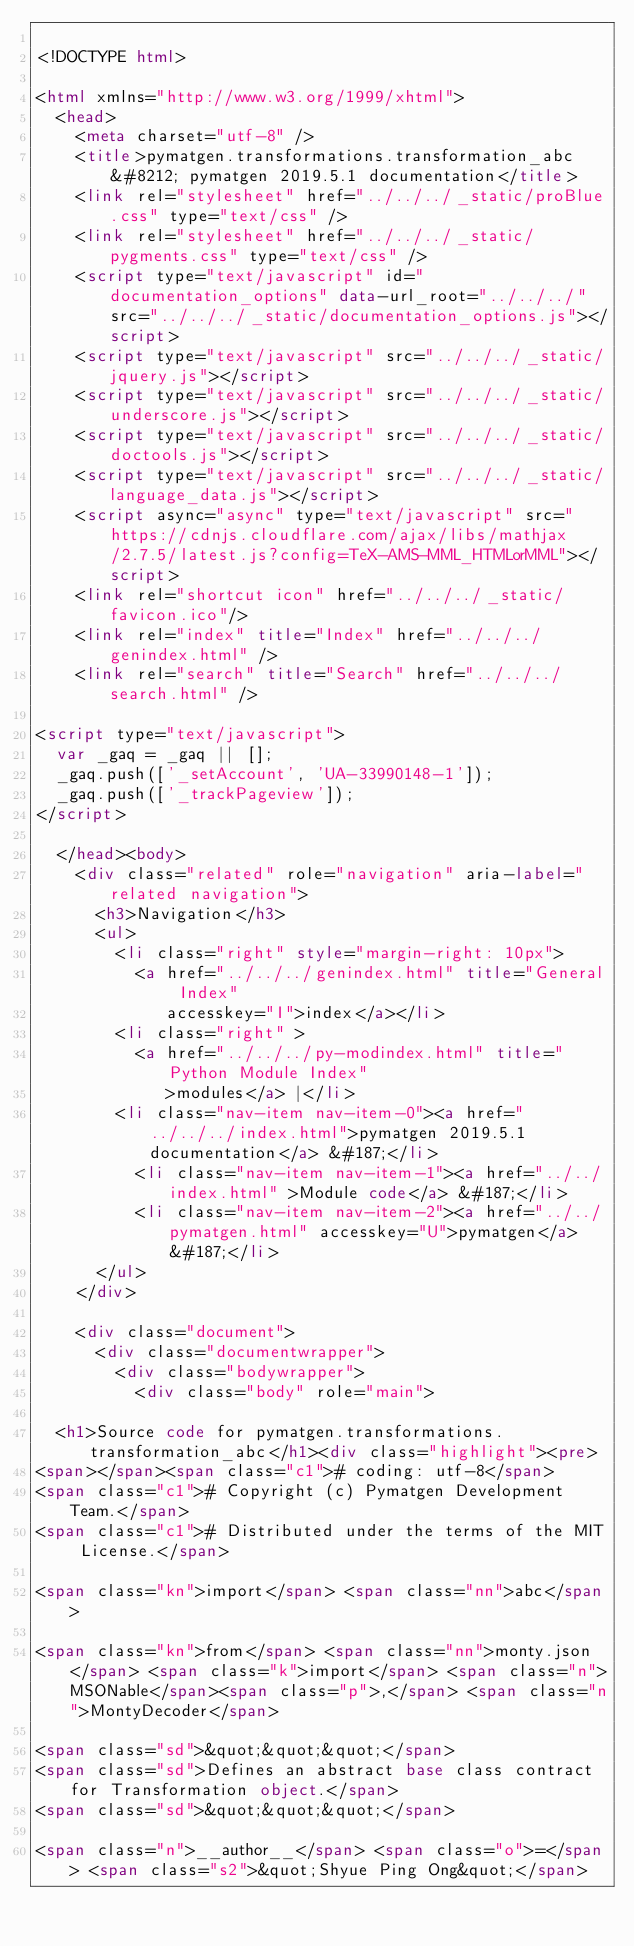Convert code to text. <code><loc_0><loc_0><loc_500><loc_500><_HTML_>
<!DOCTYPE html>

<html xmlns="http://www.w3.org/1999/xhtml">
  <head>
    <meta charset="utf-8" />
    <title>pymatgen.transformations.transformation_abc &#8212; pymatgen 2019.5.1 documentation</title>
    <link rel="stylesheet" href="../../../_static/proBlue.css" type="text/css" />
    <link rel="stylesheet" href="../../../_static/pygments.css" type="text/css" />
    <script type="text/javascript" id="documentation_options" data-url_root="../../../" src="../../../_static/documentation_options.js"></script>
    <script type="text/javascript" src="../../../_static/jquery.js"></script>
    <script type="text/javascript" src="../../../_static/underscore.js"></script>
    <script type="text/javascript" src="../../../_static/doctools.js"></script>
    <script type="text/javascript" src="../../../_static/language_data.js"></script>
    <script async="async" type="text/javascript" src="https://cdnjs.cloudflare.com/ajax/libs/mathjax/2.7.5/latest.js?config=TeX-AMS-MML_HTMLorMML"></script>
    <link rel="shortcut icon" href="../../../_static/favicon.ico"/>
    <link rel="index" title="Index" href="../../../genindex.html" />
    <link rel="search" title="Search" href="../../../search.html" />
 
<script type="text/javascript">
  var _gaq = _gaq || [];
  _gaq.push(['_setAccount', 'UA-33990148-1']);
  _gaq.push(['_trackPageview']);
</script>

  </head><body>
    <div class="related" role="navigation" aria-label="related navigation">
      <h3>Navigation</h3>
      <ul>
        <li class="right" style="margin-right: 10px">
          <a href="../../../genindex.html" title="General Index"
             accesskey="I">index</a></li>
        <li class="right" >
          <a href="../../../py-modindex.html" title="Python Module Index"
             >modules</a> |</li>
        <li class="nav-item nav-item-0"><a href="../../../index.html">pymatgen 2019.5.1 documentation</a> &#187;</li>
          <li class="nav-item nav-item-1"><a href="../../index.html" >Module code</a> &#187;</li>
          <li class="nav-item nav-item-2"><a href="../../pymatgen.html" accesskey="U">pymatgen</a> &#187;</li> 
      </ul>
    </div>  

    <div class="document">
      <div class="documentwrapper">
        <div class="bodywrapper">
          <div class="body" role="main">
            
  <h1>Source code for pymatgen.transformations.transformation_abc</h1><div class="highlight"><pre>
<span></span><span class="c1"># coding: utf-8</span>
<span class="c1"># Copyright (c) Pymatgen Development Team.</span>
<span class="c1"># Distributed under the terms of the MIT License.</span>

<span class="kn">import</span> <span class="nn">abc</span>

<span class="kn">from</span> <span class="nn">monty.json</span> <span class="k">import</span> <span class="n">MSONable</span><span class="p">,</span> <span class="n">MontyDecoder</span>

<span class="sd">&quot;&quot;&quot;</span>
<span class="sd">Defines an abstract base class contract for Transformation object.</span>
<span class="sd">&quot;&quot;&quot;</span>

<span class="n">__author__</span> <span class="o">=</span> <span class="s2">&quot;Shyue Ping Ong&quot;</span></code> 